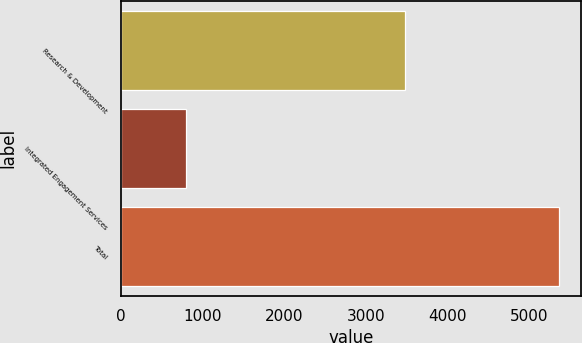Convert chart to OTSL. <chart><loc_0><loc_0><loc_500><loc_500><bar_chart><fcel>Research & Development<fcel>Integrated Engagement Services<fcel>Total<nl><fcel>3472<fcel>796<fcel>5364<nl></chart> 